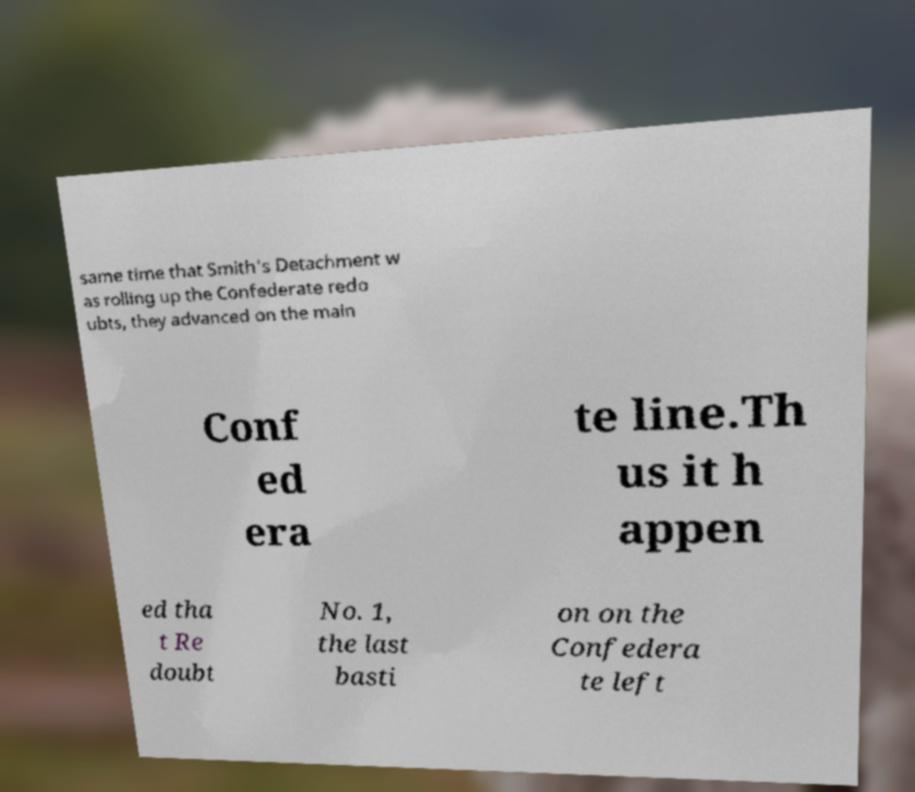What messages or text are displayed in this image? I need them in a readable, typed format. same time that Smith's Detachment w as rolling up the Confederate redo ubts, they advanced on the main Conf ed era te line.Th us it h appen ed tha t Re doubt No. 1, the last basti on on the Confedera te left 